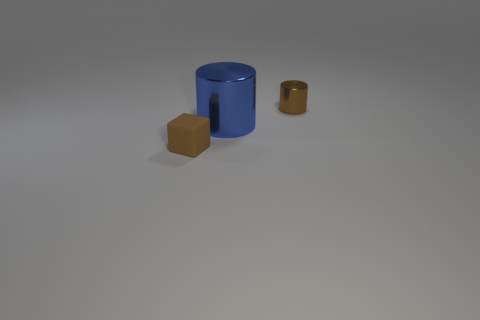Add 2 small rubber blocks. How many objects exist? 5 Subtract all cubes. How many objects are left? 2 Add 1 large blue metal balls. How many large blue metal balls exist? 1 Subtract 1 brown cylinders. How many objects are left? 2 Subtract all tiny yellow matte objects. Subtract all brown things. How many objects are left? 1 Add 1 big blue objects. How many big blue objects are left? 2 